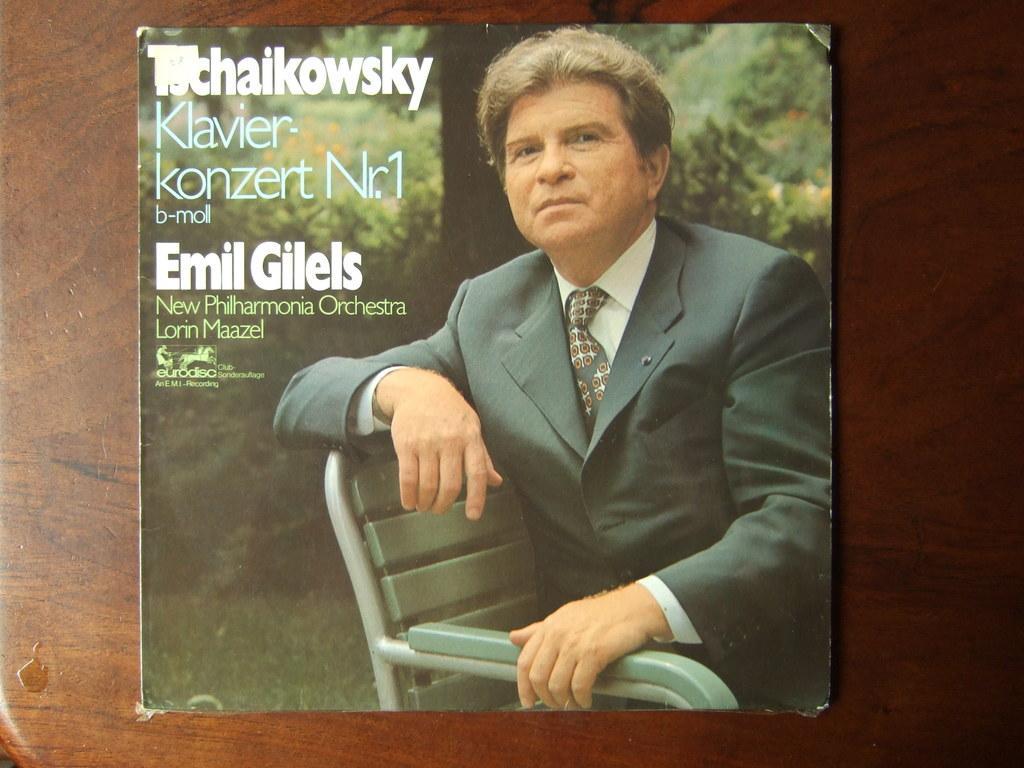Please provide a concise description of this image. In this picture we can see an image of a man sitting on a chair and the card is on the wooden surface. Behind the man, there are trees and something is written on the card. 